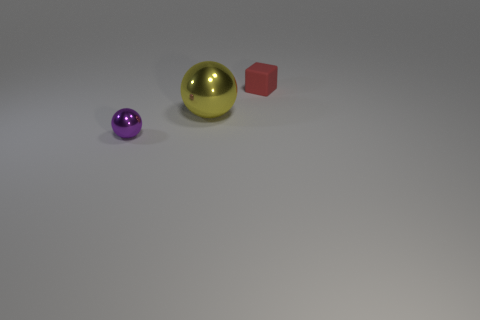There is a metallic sphere that is on the left side of the yellow thing; does it have the same size as the red matte object?
Your response must be concise. Yes. Is the color of the big metallic sphere the same as the tiny sphere?
Your response must be concise. No. What number of balls are both to the right of the purple sphere and on the left side of the big thing?
Ensure brevity in your answer.  0. There is a small object that is in front of the small red cube behind the tiny metal object; how many purple metal balls are behind it?
Offer a very short reply. 0. The small matte thing is what shape?
Keep it short and to the point. Cube. How many tiny blocks have the same material as the big thing?
Make the answer very short. 0. The big object that is the same material as the purple sphere is what color?
Ensure brevity in your answer.  Yellow. Do the matte cube and the shiny thing that is on the right side of the small sphere have the same size?
Make the answer very short. No. What material is the thing that is behind the metallic sphere that is behind the tiny object that is to the left of the large yellow shiny sphere?
Your answer should be very brief. Rubber. How many objects are spheres or small things?
Keep it short and to the point. 3. 